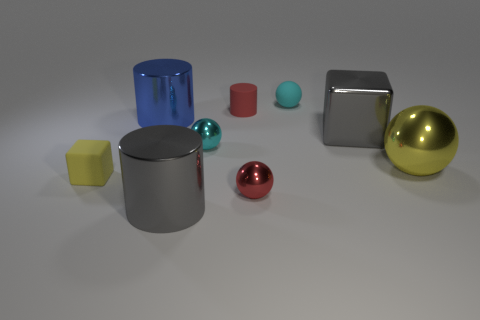Are there any patterns or symmetry in the arrangement of these objects? The arrangement doesn't exhibit an obvious pattern or symmetry. The objects are placed in an almost random spread, yet they are evenly spaced, which provides a sense of balance within the composition. 